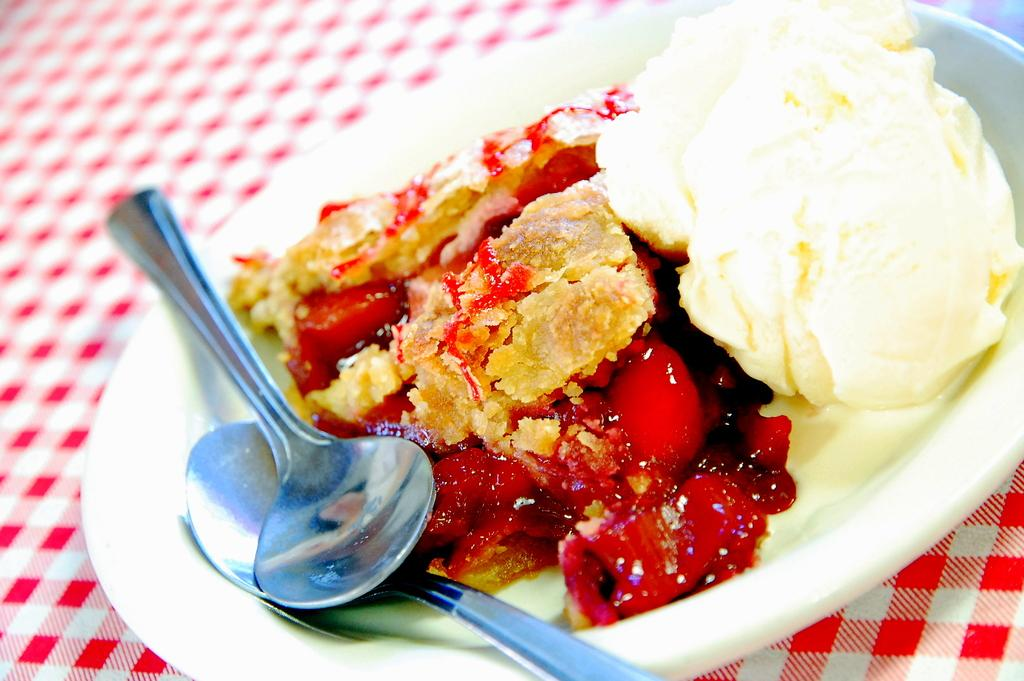What type of furniture is present in the image? There is a table in the image. What is covering the table? The table has a table cloth. What is on the table? There is a white plate on the table. What is on the plate? The plate contains ice cream. What is added to the ice cream as a decoration? The ice cream has fruit garnish. How many spoons are in the plate? There are two spoons in the plate. What type of cannon is present on the table in the image? There is no cannon present on the table in the image. How many letters are on the table cloth in the image? There is no mention of letters on the table cloth in the image. 